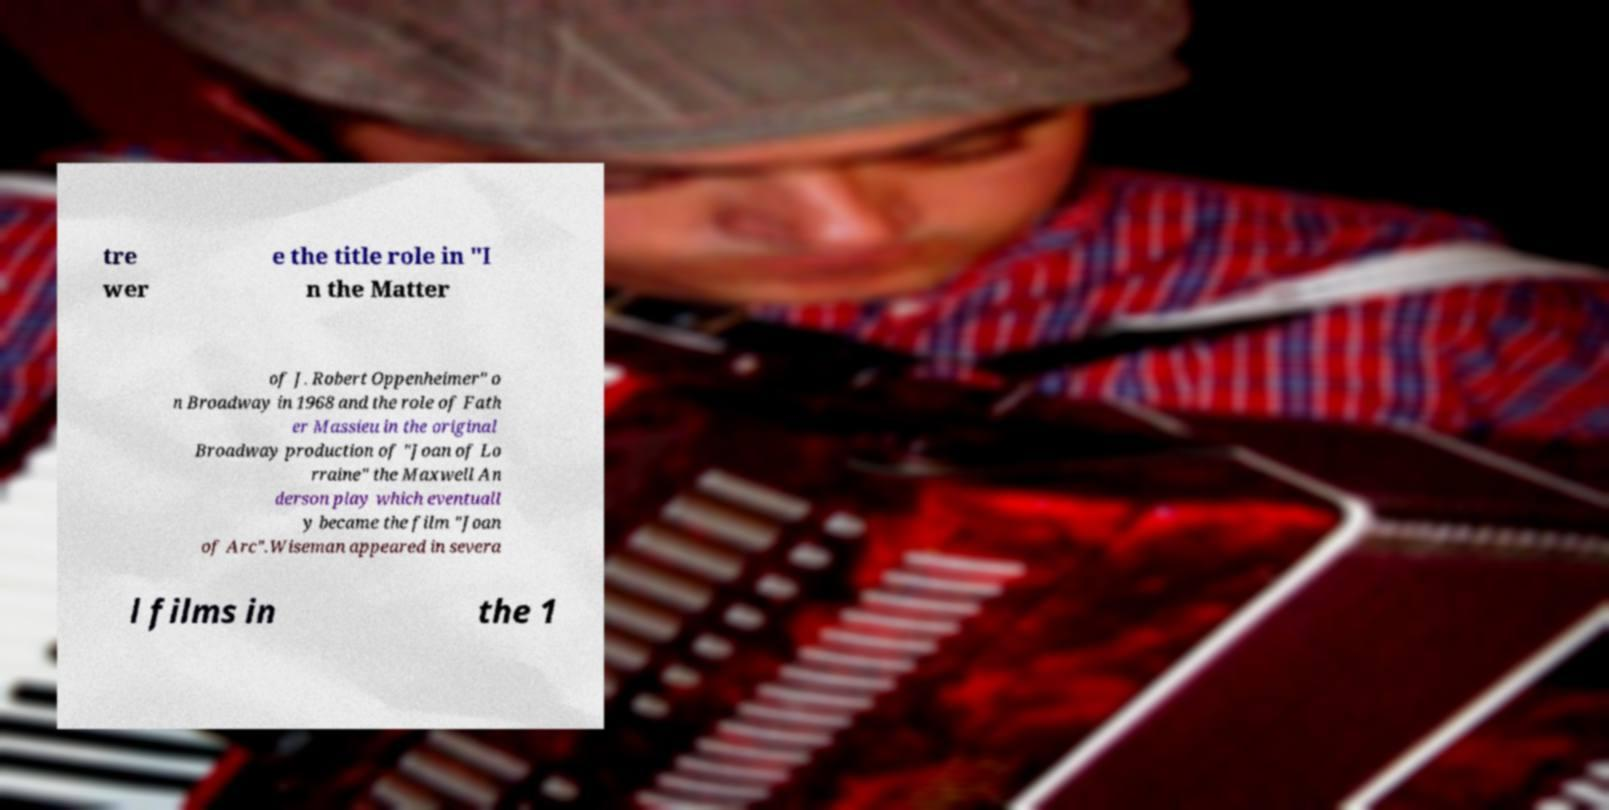Please identify and transcribe the text found in this image. tre wer e the title role in "I n the Matter of J. Robert Oppenheimer" o n Broadway in 1968 and the role of Fath er Massieu in the original Broadway production of "Joan of Lo rraine" the Maxwell An derson play which eventuall y became the film "Joan of Arc".Wiseman appeared in severa l films in the 1 